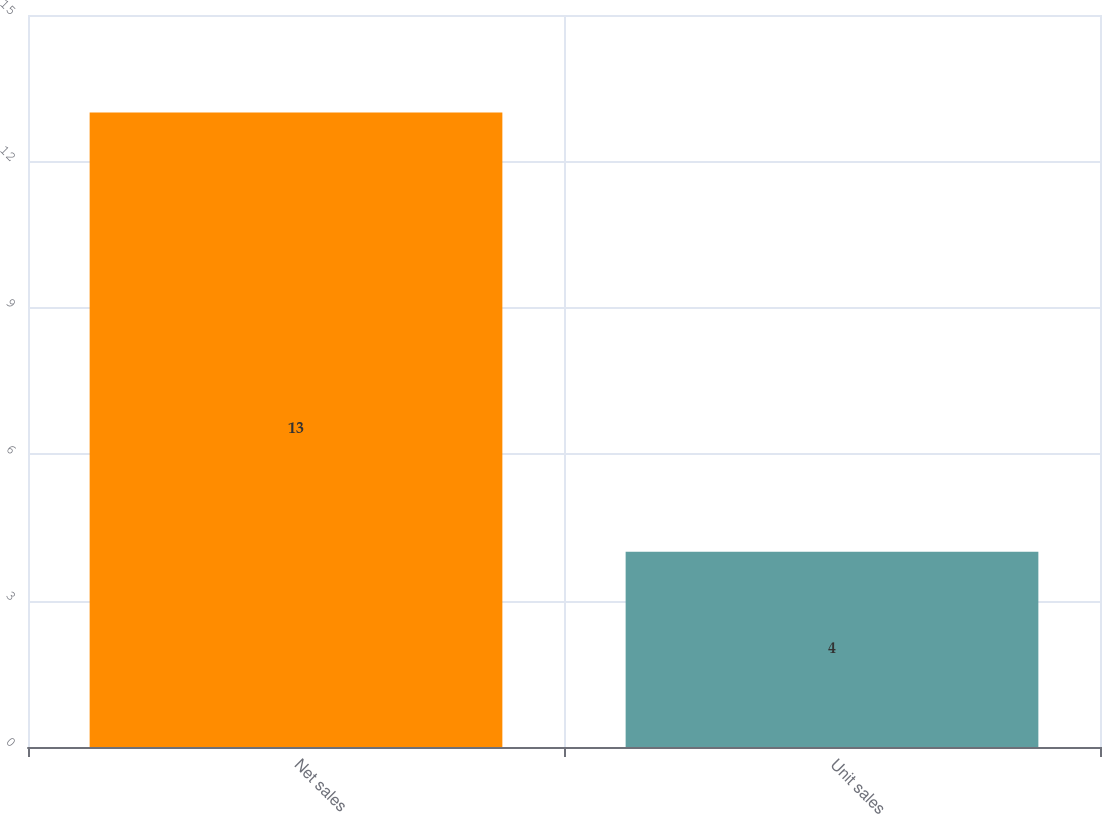Convert chart to OTSL. <chart><loc_0><loc_0><loc_500><loc_500><bar_chart><fcel>Net sales<fcel>Unit sales<nl><fcel>13<fcel>4<nl></chart> 